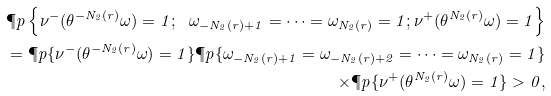Convert formula to latex. <formula><loc_0><loc_0><loc_500><loc_500>\P p \left \{ \nu ^ { - } ( \theta ^ { - N _ { 2 } ( r ) } \omega ) = 1 ; \ \omega _ { - N _ { 2 } ( r ) + 1 } = \dots = \omega _ { N _ { 2 } ( r ) } = 1 ; \nu ^ { + } ( \theta ^ { N _ { 2 } ( r ) } \omega ) = 1 \right \} \\ = \P p \{ \nu ^ { - } ( \theta ^ { - N _ { 2 } ( r ) } \omega ) = 1 \} \P p \{ \omega _ { - N _ { 2 } ( r ) + 1 } = \omega _ { - N _ { 2 } ( r ) + 2 } = \dots = \omega _ { N _ { 2 } ( r ) } = 1 \} \\ \times \P p \{ \nu ^ { + } ( \theta ^ { N _ { 2 } ( r ) } \omega ) = 1 \} > 0 ,</formula> 